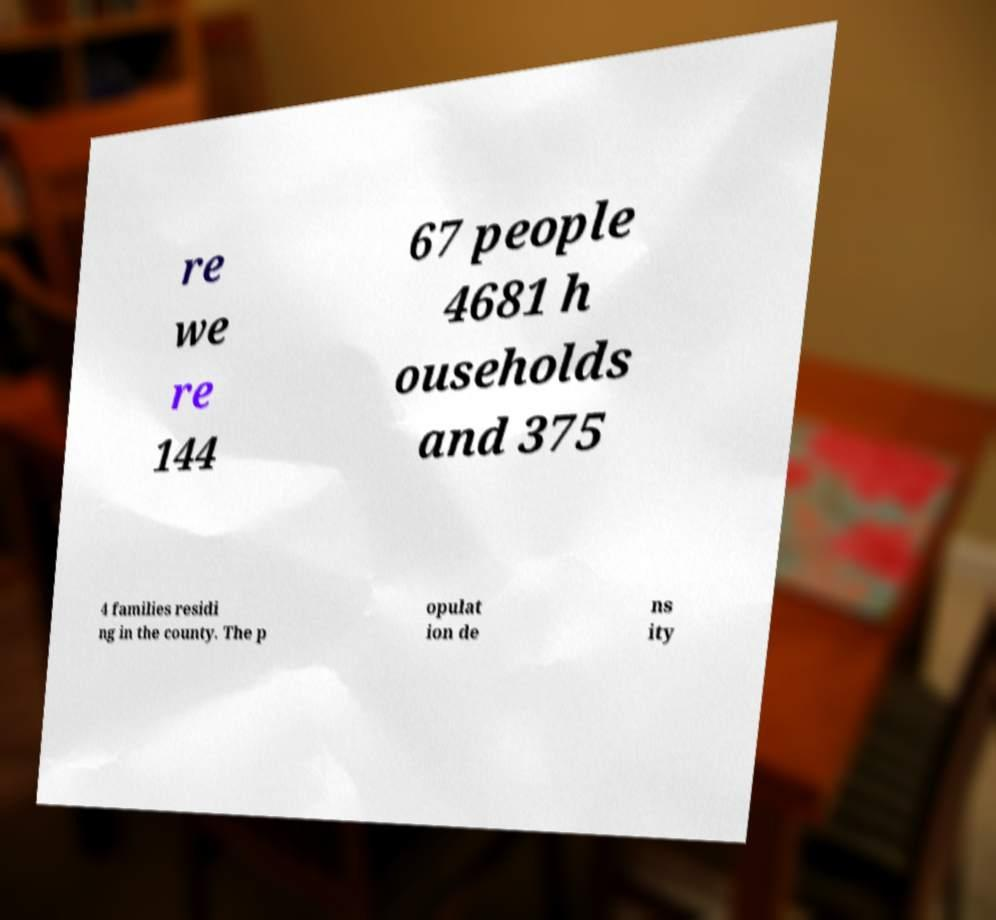There's text embedded in this image that I need extracted. Can you transcribe it verbatim? re we re 144 67 people 4681 h ouseholds and 375 4 families residi ng in the county. The p opulat ion de ns ity 